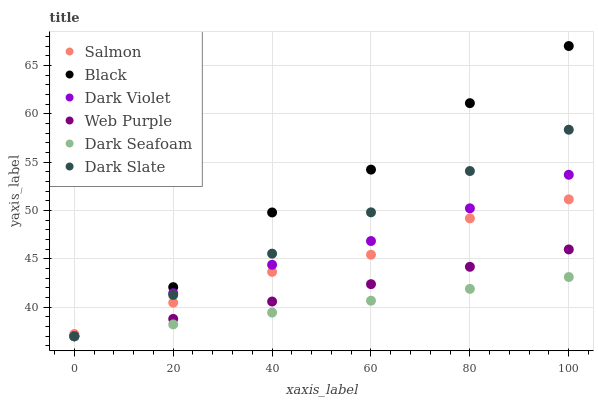Does Dark Seafoam have the minimum area under the curve?
Answer yes or no. Yes. Does Black have the maximum area under the curve?
Answer yes or no. Yes. Does Dark Violet have the minimum area under the curve?
Answer yes or no. No. Does Dark Violet have the maximum area under the curve?
Answer yes or no. No. Is Dark Seafoam the smoothest?
Answer yes or no. Yes. Is Black the roughest?
Answer yes or no. Yes. Is Dark Violet the smoothest?
Answer yes or no. No. Is Dark Violet the roughest?
Answer yes or no. No. Does Dark Seafoam have the lowest value?
Answer yes or no. Yes. Does Black have the highest value?
Answer yes or no. Yes. Does Dark Violet have the highest value?
Answer yes or no. No. Is Web Purple less than Salmon?
Answer yes or no. Yes. Is Salmon greater than Dark Seafoam?
Answer yes or no. Yes. Does Dark Violet intersect Web Purple?
Answer yes or no. Yes. Is Dark Violet less than Web Purple?
Answer yes or no. No. Is Dark Violet greater than Web Purple?
Answer yes or no. No. Does Web Purple intersect Salmon?
Answer yes or no. No. 